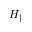<formula> <loc_0><loc_0><loc_500><loc_500>H _ { \| }</formula> 